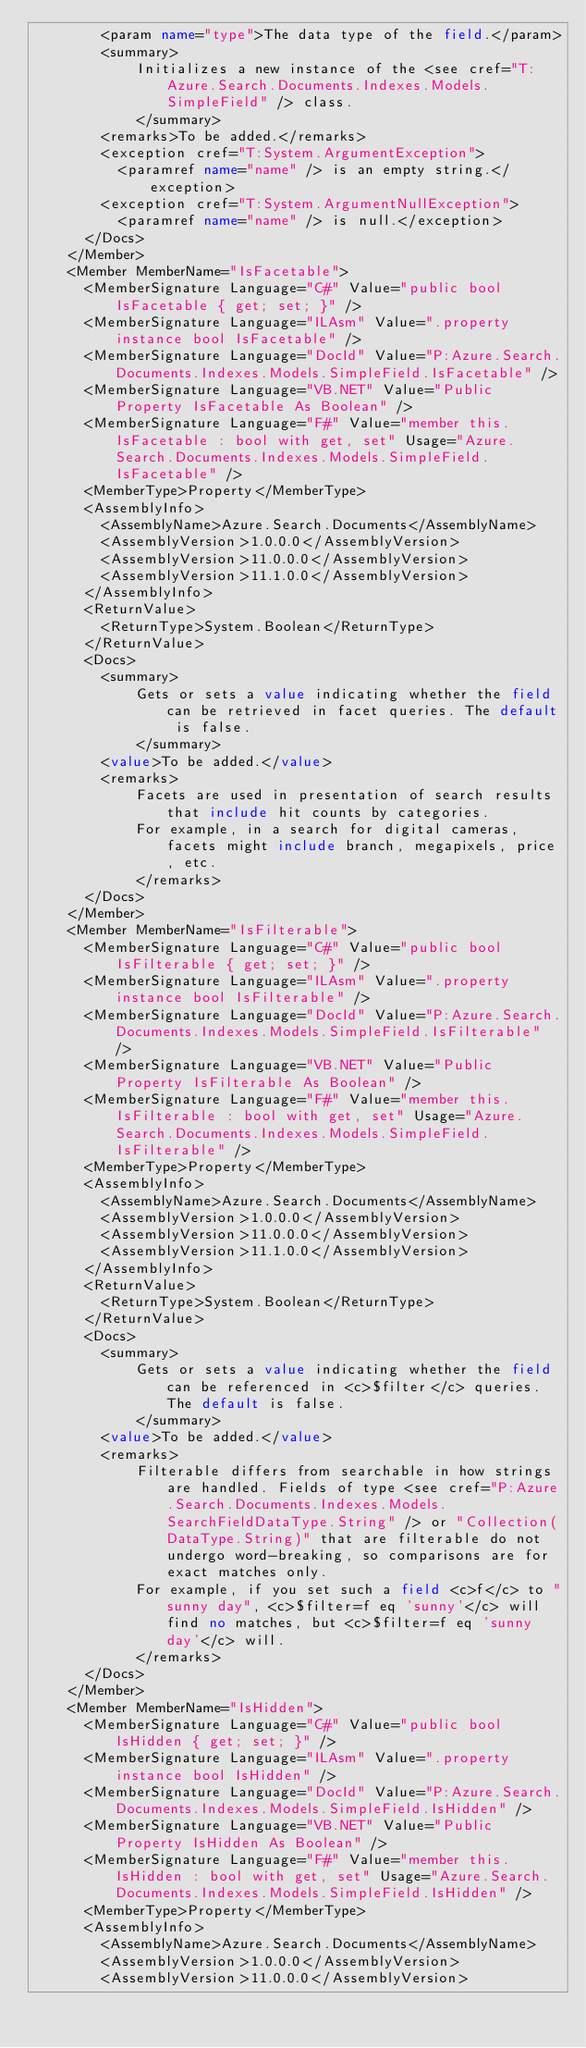Convert code to text. <code><loc_0><loc_0><loc_500><loc_500><_XML_>        <param name="type">The data type of the field.</param>
        <summary>
            Initializes a new instance of the <see cref="T:Azure.Search.Documents.Indexes.Models.SimpleField" /> class.
            </summary>
        <remarks>To be added.</remarks>
        <exception cref="T:System.ArgumentException">
          <paramref name="name" /> is an empty string.</exception>
        <exception cref="T:System.ArgumentNullException">
          <paramref name="name" /> is null.</exception>
      </Docs>
    </Member>
    <Member MemberName="IsFacetable">
      <MemberSignature Language="C#" Value="public bool IsFacetable { get; set; }" />
      <MemberSignature Language="ILAsm" Value=".property instance bool IsFacetable" />
      <MemberSignature Language="DocId" Value="P:Azure.Search.Documents.Indexes.Models.SimpleField.IsFacetable" />
      <MemberSignature Language="VB.NET" Value="Public Property IsFacetable As Boolean" />
      <MemberSignature Language="F#" Value="member this.IsFacetable : bool with get, set" Usage="Azure.Search.Documents.Indexes.Models.SimpleField.IsFacetable" />
      <MemberType>Property</MemberType>
      <AssemblyInfo>
        <AssemblyName>Azure.Search.Documents</AssemblyName>
        <AssemblyVersion>1.0.0.0</AssemblyVersion>
        <AssemblyVersion>11.0.0.0</AssemblyVersion>
        <AssemblyVersion>11.1.0.0</AssemblyVersion>
      </AssemblyInfo>
      <ReturnValue>
        <ReturnType>System.Boolean</ReturnType>
      </ReturnValue>
      <Docs>
        <summary>
            Gets or sets a value indicating whether the field can be retrieved in facet queries. The default is false.
            </summary>
        <value>To be added.</value>
        <remarks>
            Facets are used in presentation of search results that include hit counts by categories.
            For example, in a search for digital cameras, facets might include branch, megapixels, price, etc.
            </remarks>
      </Docs>
    </Member>
    <Member MemberName="IsFilterable">
      <MemberSignature Language="C#" Value="public bool IsFilterable { get; set; }" />
      <MemberSignature Language="ILAsm" Value=".property instance bool IsFilterable" />
      <MemberSignature Language="DocId" Value="P:Azure.Search.Documents.Indexes.Models.SimpleField.IsFilterable" />
      <MemberSignature Language="VB.NET" Value="Public Property IsFilterable As Boolean" />
      <MemberSignature Language="F#" Value="member this.IsFilterable : bool with get, set" Usage="Azure.Search.Documents.Indexes.Models.SimpleField.IsFilterable" />
      <MemberType>Property</MemberType>
      <AssemblyInfo>
        <AssemblyName>Azure.Search.Documents</AssemblyName>
        <AssemblyVersion>1.0.0.0</AssemblyVersion>
        <AssemblyVersion>11.0.0.0</AssemblyVersion>
        <AssemblyVersion>11.1.0.0</AssemblyVersion>
      </AssemblyInfo>
      <ReturnValue>
        <ReturnType>System.Boolean</ReturnType>
      </ReturnValue>
      <Docs>
        <summary>
            Gets or sets a value indicating whether the field can be referenced in <c>$filter</c> queries. The default is false.
            </summary>
        <value>To be added.</value>
        <remarks>
            Filterable differs from searchable in how strings are handled. Fields of type <see cref="P:Azure.Search.Documents.Indexes.Models.SearchFieldDataType.String" /> or "Collection(DataType.String)" that are filterable do not undergo word-breaking, so comparisons are for exact matches only.
            For example, if you set such a field <c>f</c> to "sunny day", <c>$filter=f eq 'sunny'</c> will find no matches, but <c>$filter=f eq 'sunny day'</c> will.
            </remarks>
      </Docs>
    </Member>
    <Member MemberName="IsHidden">
      <MemberSignature Language="C#" Value="public bool IsHidden { get; set; }" />
      <MemberSignature Language="ILAsm" Value=".property instance bool IsHidden" />
      <MemberSignature Language="DocId" Value="P:Azure.Search.Documents.Indexes.Models.SimpleField.IsHidden" />
      <MemberSignature Language="VB.NET" Value="Public Property IsHidden As Boolean" />
      <MemberSignature Language="F#" Value="member this.IsHidden : bool with get, set" Usage="Azure.Search.Documents.Indexes.Models.SimpleField.IsHidden" />
      <MemberType>Property</MemberType>
      <AssemblyInfo>
        <AssemblyName>Azure.Search.Documents</AssemblyName>
        <AssemblyVersion>1.0.0.0</AssemblyVersion>
        <AssemblyVersion>11.0.0.0</AssemblyVersion></code> 